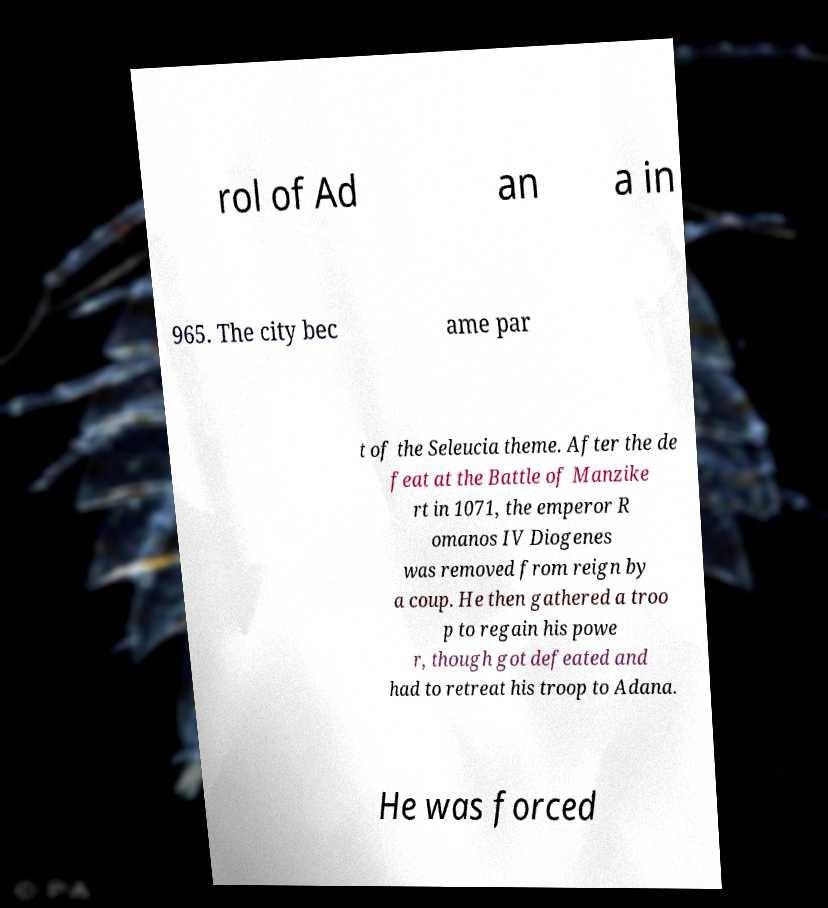Could you assist in decoding the text presented in this image and type it out clearly? rol of Ad an a in 965. The city bec ame par t of the Seleucia theme. After the de feat at the Battle of Manzike rt in 1071, the emperor R omanos IV Diogenes was removed from reign by a coup. He then gathered a troo p to regain his powe r, though got defeated and had to retreat his troop to Adana. He was forced 